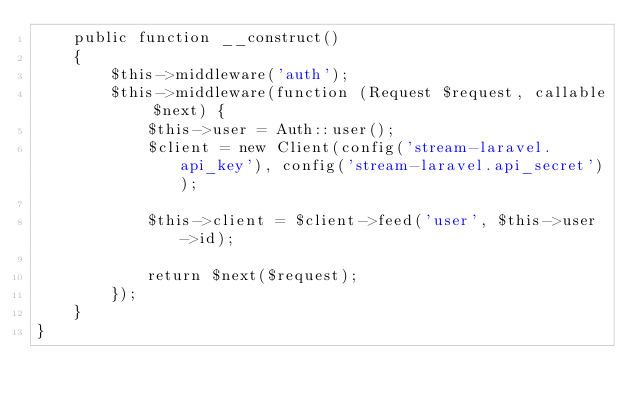Convert code to text. <code><loc_0><loc_0><loc_500><loc_500><_PHP_>    public function __construct()
    {
        $this->middleware('auth');
        $this->middleware(function (Request $request, callable $next) {
            $this->user = Auth::user();
            $client = new Client(config('stream-laravel.api_key'), config('stream-laravel.api_secret'));

            $this->client = $client->feed('user', $this->user->id);

            return $next($request);
        });
    }
}
</code> 